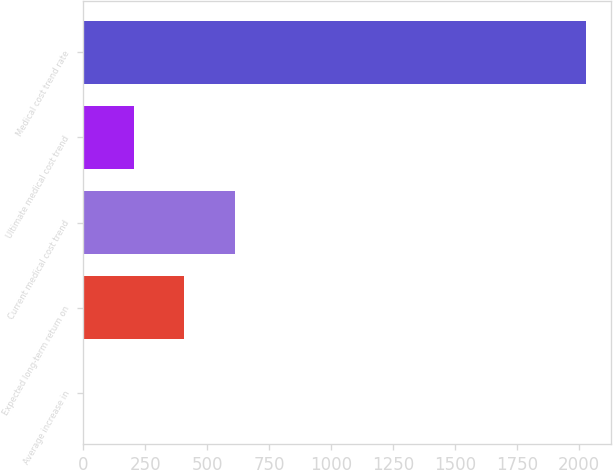<chart> <loc_0><loc_0><loc_500><loc_500><bar_chart><fcel>Average increase in<fcel>Expected long-term return on<fcel>Current medical cost trend<fcel>Ultimate medical cost trend<fcel>Medical cost trend rate<nl><fcel>3.5<fcel>408.4<fcel>610.85<fcel>205.95<fcel>2028<nl></chart> 